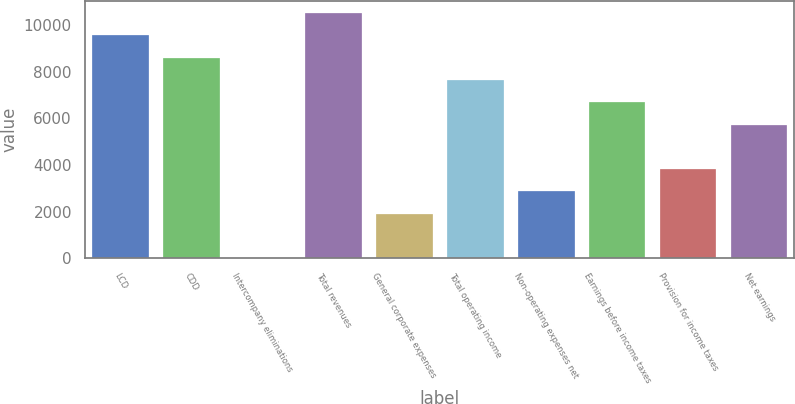<chart> <loc_0><loc_0><loc_500><loc_500><bar_chart><fcel>LCD<fcel>CDD<fcel>Intercompany eliminations<fcel>Total revenues<fcel>General corporate expenses<fcel>Total operating income<fcel>Non-operating expenses net<fcel>Earnings before income taxes<fcel>Provision for income taxes<fcel>Net earnings<nl><fcel>9552.9<fcel>8597.66<fcel>0.5<fcel>10508.1<fcel>1910.98<fcel>7642.42<fcel>2866.22<fcel>6687.18<fcel>3821.46<fcel>5731.94<nl></chart> 